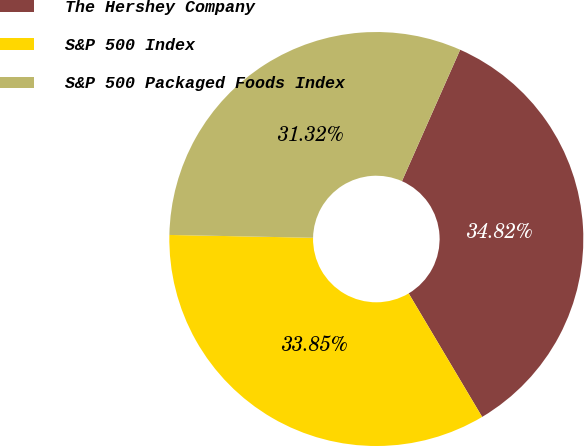Convert chart to OTSL. <chart><loc_0><loc_0><loc_500><loc_500><pie_chart><fcel>The Hershey Company<fcel>S&P 500 Index<fcel>S&P 500 Packaged Foods Index<nl><fcel>34.82%<fcel>33.85%<fcel>31.32%<nl></chart> 